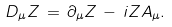Convert formula to latex. <formula><loc_0><loc_0><loc_500><loc_500>D _ { \mu } Z \, = \, \partial _ { \mu } Z \, - \, i Z A _ { \mu } .</formula> 